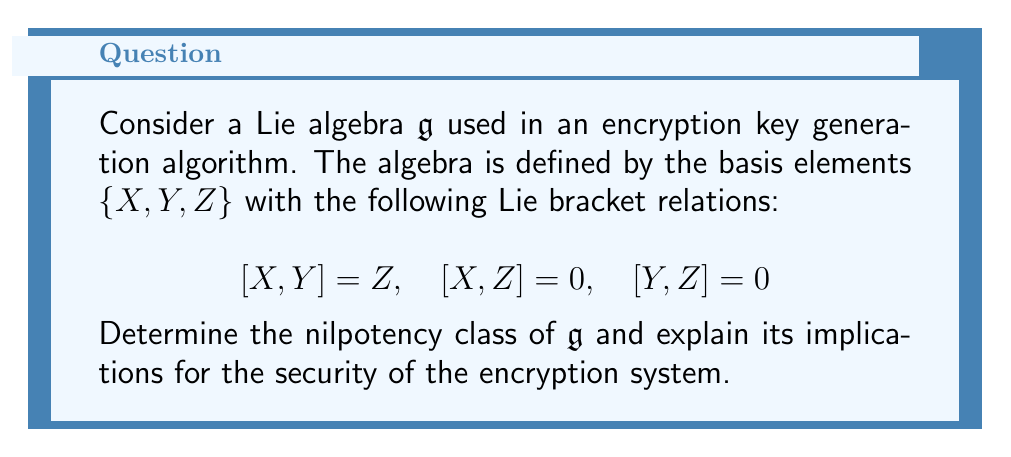Can you answer this question? To analyze the nilpotency of the given Lie algebra $\mathfrak{g}$, we need to examine its lower central series. The steps are as follows:

1) First, let's recall the definition of the lower central series:
   $\mathfrak{g}_1 = \mathfrak{g}$
   $\mathfrak{g}_{i+1} = [\mathfrak{g}, \mathfrak{g}_i]$ for $i \geq 1$

2) Let's compute the terms of this series:

   $\mathfrak{g}_1 = \mathfrak{g} = \text{span}\{X, Y, Z\}$

   $\mathfrak{g}_2 = [\mathfrak{g}, \mathfrak{g}_1] = \text{span}\{[X,Y], [X,Z], [Y,Z]\} = \text{span}\{Z\}$

   $\mathfrak{g}_3 = [\mathfrak{g}, \mathfrak{g}_2] = \text{span}\{[X,Z], [Y,Z]\} = \{0\}$

3) We see that the series terminates at $\mathfrak{g}_3 = \{0\}$. This means that $\mathfrak{g}$ is nilpotent with nilpotency class 2.

4) The nilpotency class of a Lie algebra is defined as the smallest positive integer $k$ such that $\mathfrak{g}_{k+1} = \{0\}$. In this case, $k = 2$.

Implications for encryption security:

a) Nilpotent Lie algebras have a simpler structure compared to general Lie algebras, which can make them more predictable in certain contexts.

b) The nilpotency class of 2 indicates a relatively simple algebraic structure, which might be vulnerable to certain types of cryptanalysis.

c) However, the simplicity of the algebra could also lead to more efficient key generation algorithms, potentially allowing for faster encryption and decryption processes.

d) The regulatory authority should carefully evaluate whether this level of algebraic complexity provides sufficient security for the intended application, considering both the potential vulnerabilities and the computational efficiency.
Answer: The Lie algebra $\mathfrak{g}$ is nilpotent with nilpotency class 2. This implies a relatively simple algebraic structure, which may offer computational efficiency but could potentially be vulnerable to certain cryptanalytic attacks. A thorough security assessment is recommended to ensure compliance with encryption standards in fintech applications. 